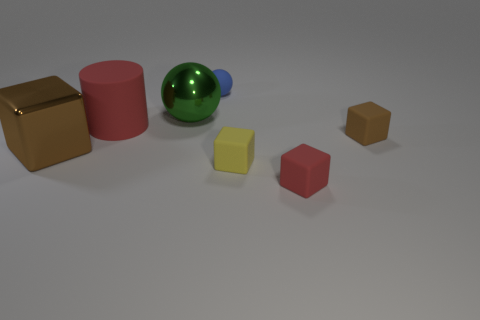What number of green things are balls or large metallic spheres?
Your answer should be compact. 1. What number of objects are red matte blocks or matte things on the right side of the green metallic object?
Offer a terse response. 4. What material is the brown object right of the small yellow matte cube?
Your response must be concise. Rubber. There is a blue rubber object that is the same size as the brown rubber thing; what is its shape?
Keep it short and to the point. Sphere. Are there any other rubber things that have the same shape as the small blue matte object?
Provide a short and direct response. No. Are the tiny blue sphere and the cube that is to the left of the green object made of the same material?
Offer a very short reply. No. There is a red object in front of the brown block left of the big green thing; what is it made of?
Provide a short and direct response. Rubber. Is the number of tiny blue matte spheres that are behind the large red object greater than the number of small red matte cubes?
Give a very brief answer. No. Are any big green blocks visible?
Your answer should be very brief. No. There is a metallic thing that is behind the cylinder; what is its color?
Your answer should be compact. Green. 